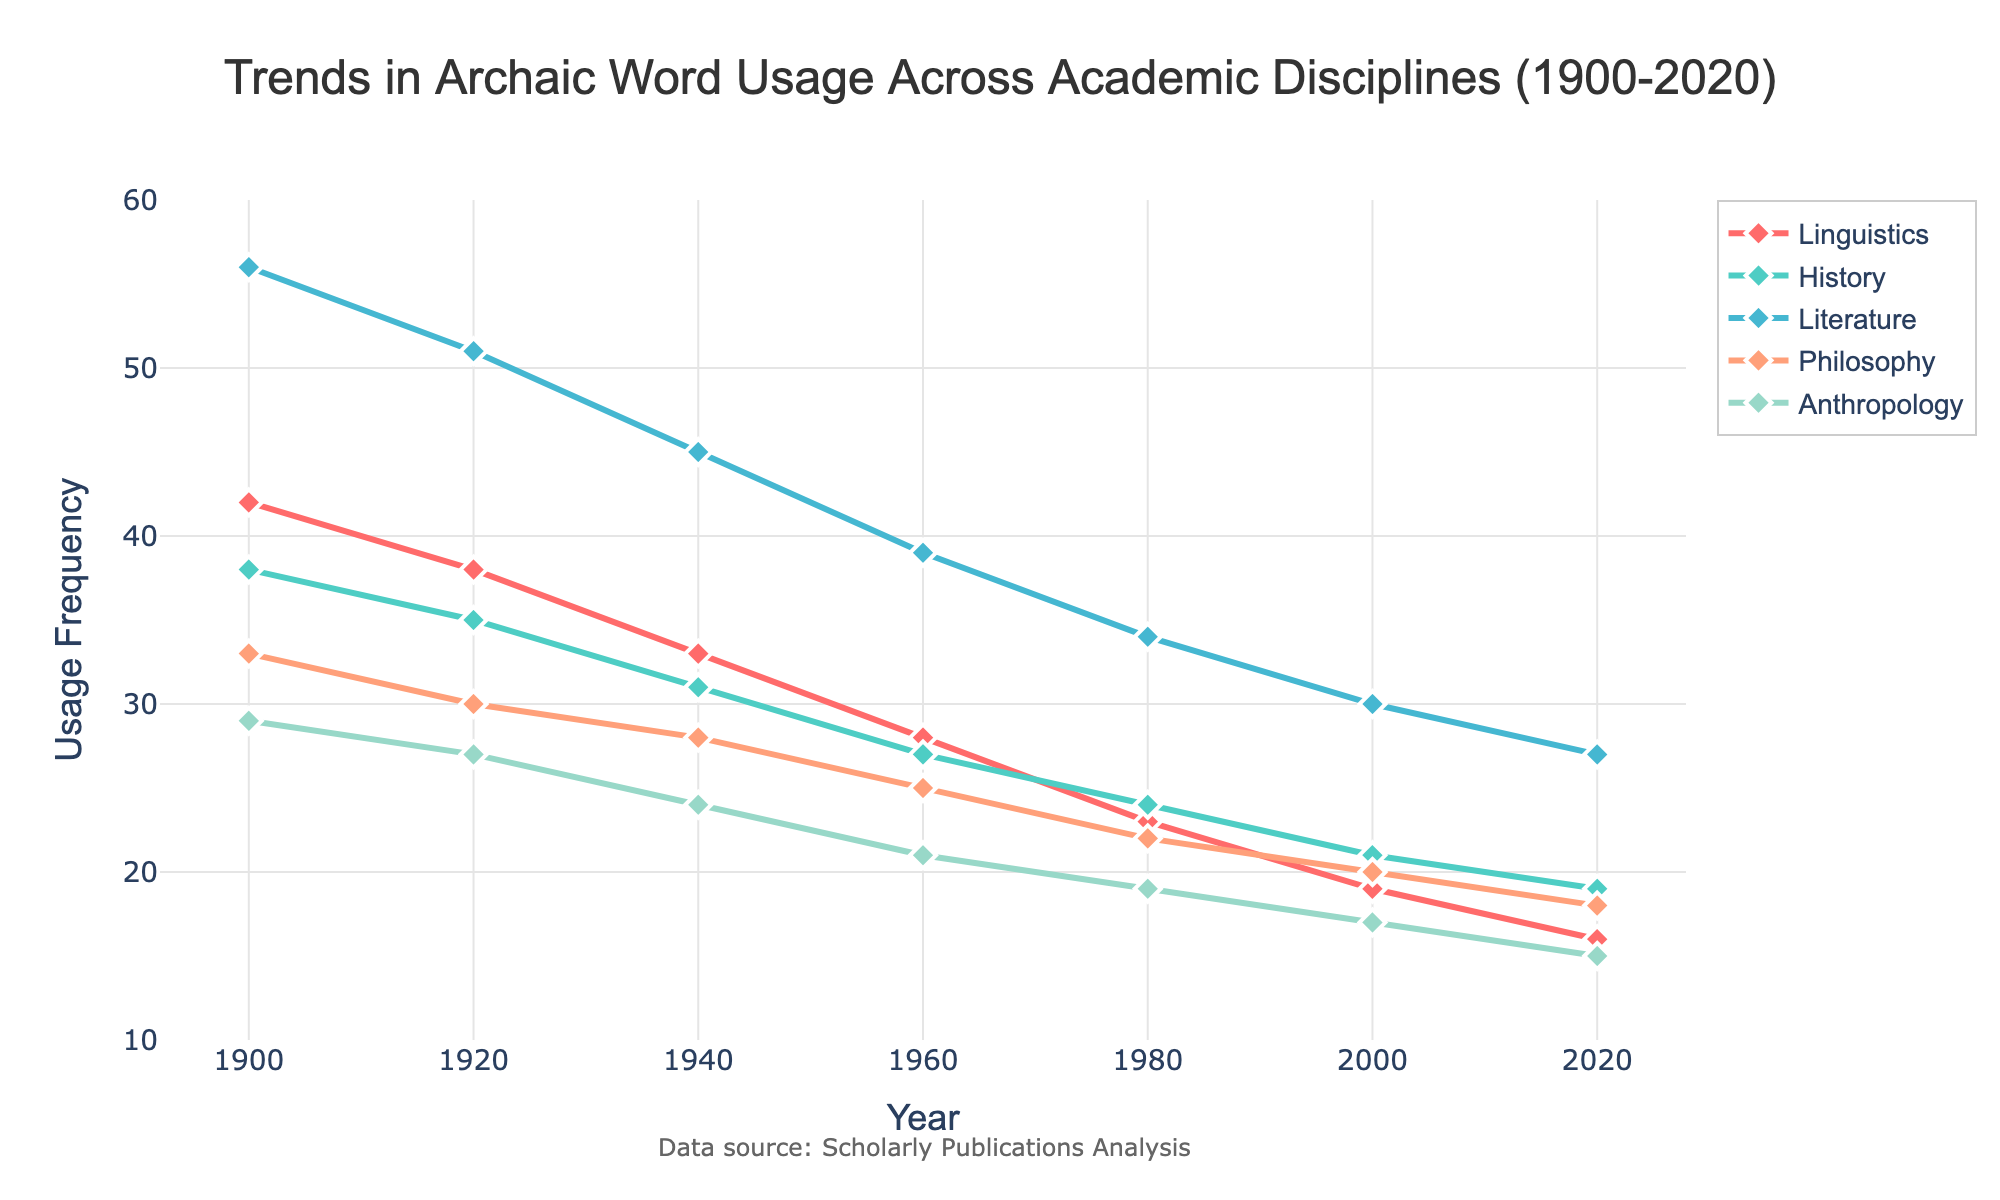What was the usage frequency of archaic words in the field of Literature in 1960? Look at the point corresponding to 1960 on the Literature line. The value is 39.
Answer: 39 Among the disciplines shown, which had the least usage of archaic words in 2020? Compare the usage frequencies of all disciplines in 2020. Anthropology has the lowest value at 15.
Answer: Anthropology What is the difference in usage frequency of archaic words between History and Linguistics in 1940? Subtract the usage frequency of History (31) from Linguistics (33) in 1940: 33 - 31 = 2.
Answer: 2 Which discipline showed the greatest reduction in usage frequency of archaic words from 1900 to 2020? Calculate the difference for each discipline between 1900 and 2020:
- Linguistics: 42 - 16 = 26
- History: 38 - 19 = 19
- Literature: 56 - 27 = 29
- Philosophy: 33 - 18 = 15
- Anthropology: 29 - 15 = 14
Literature has the greatest reduction of 29.
Answer: Literature What's the total usage frequency of archaic words for all disciplines combined in 2000? Add the usage frequencies for all disciplines in the year 2000:
19 (Linguistics) + 21 (History) + 30 (Literature) + 20 (Philosophy) + 17 (Anthropology) = 107.
Answer: 107 In which year did Linguistics and History both experience a usage frequency of 24 or fewer? Check the years where both Linguistics and History values are ≤ 24: In 1980, Linguistics is 23 and History is 24.
Answer: 1980 Is there any discipline that had consistently decreasing usage frequency throughout the period from 1900 to 2020? Check each discipline's trend over the years.
- Linguistics: Decreasing trend
- History: Decreasing trend
- Literature: Decreasing trend
- Philosophy: Decreasing trend
- Anthropology: Decreasing trend
All disciplines show consistently decreasing trends.
Answer: Yes During which decade did Philosophy experience the smallest decrease in usage frequency of archaic words? Calculate the changes per decade:
- 1900-1920: 33 - 30 = 3
- 1920-1940: 30 - 28 = 2
- 1940-1960: 28 - 25 = 3
- 1960-1980: 25 - 22 = 3
- 1980-2000: 22 - 20 = 2
- 2000-2020: 20 - 18 = 2
The smallest decrease was 2, occurring in the decades 1920-1940, 1980-2000, and 2000-2020.
Answer: 1920-1940, 1980-2000, 2000-2020 Which discipline had the closest usage frequency of archaic words to Philosophy in the year 2000? Compare the value for Philosophy (20) in 2000 to the values in other disciplines:
- Linguistics: 19
- History: 21
- Literature: 30
- Anthropology: 17
Linguistics and History are both 1 unit apart.
Answer: Linguistics and History 